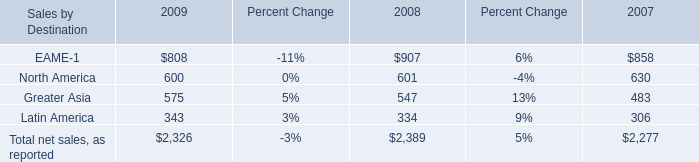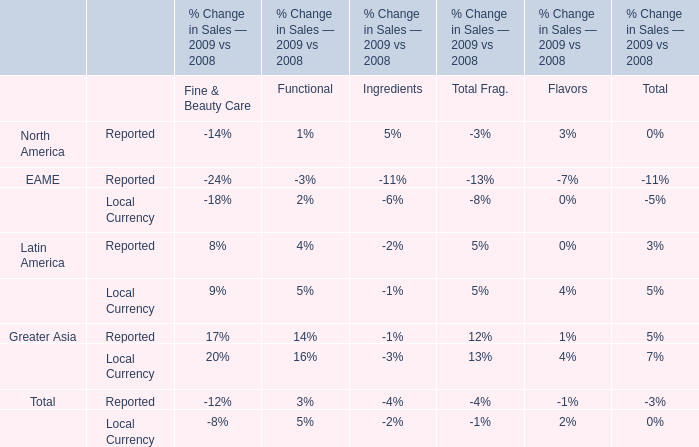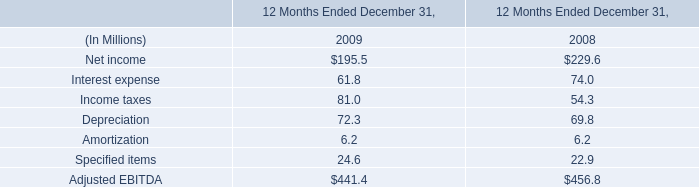what is the 2011 total interest expense in billions based on the weighted-average debt level and effective interest rate? 
Computations: (9.2 * 6.2%)
Answer: 0.5704. 